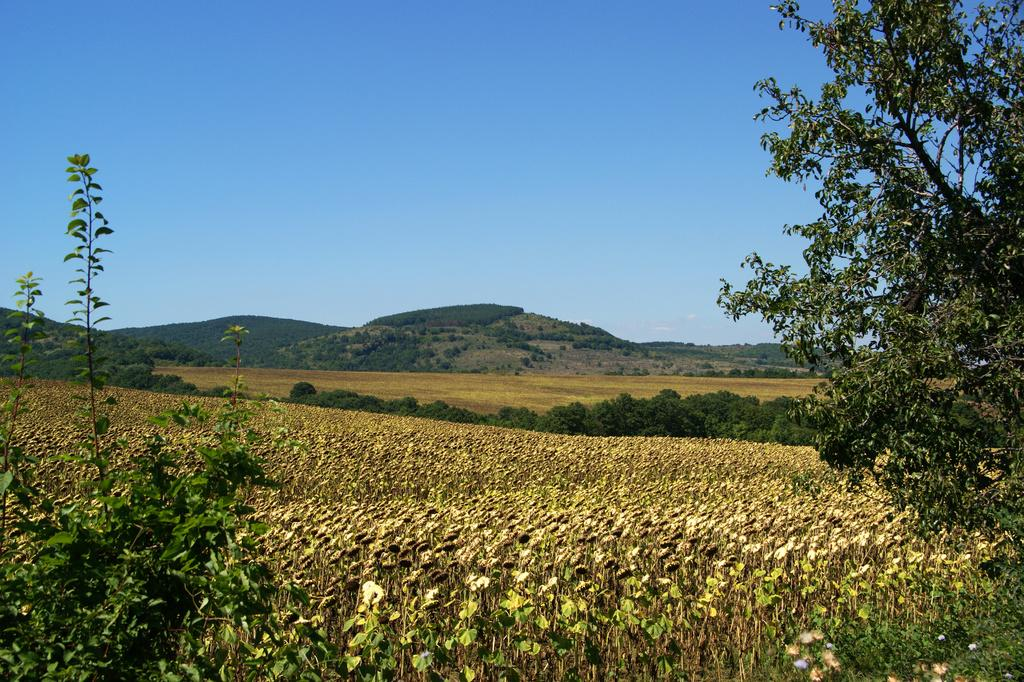What type of vegetation or plants can be seen at the bottom of the image? There is greenery at the bottom side of the image. What type of polish is being applied to the leaves in the image? There is no polish or any indication of polishing in the image; it only features greenery at the bottom side. 